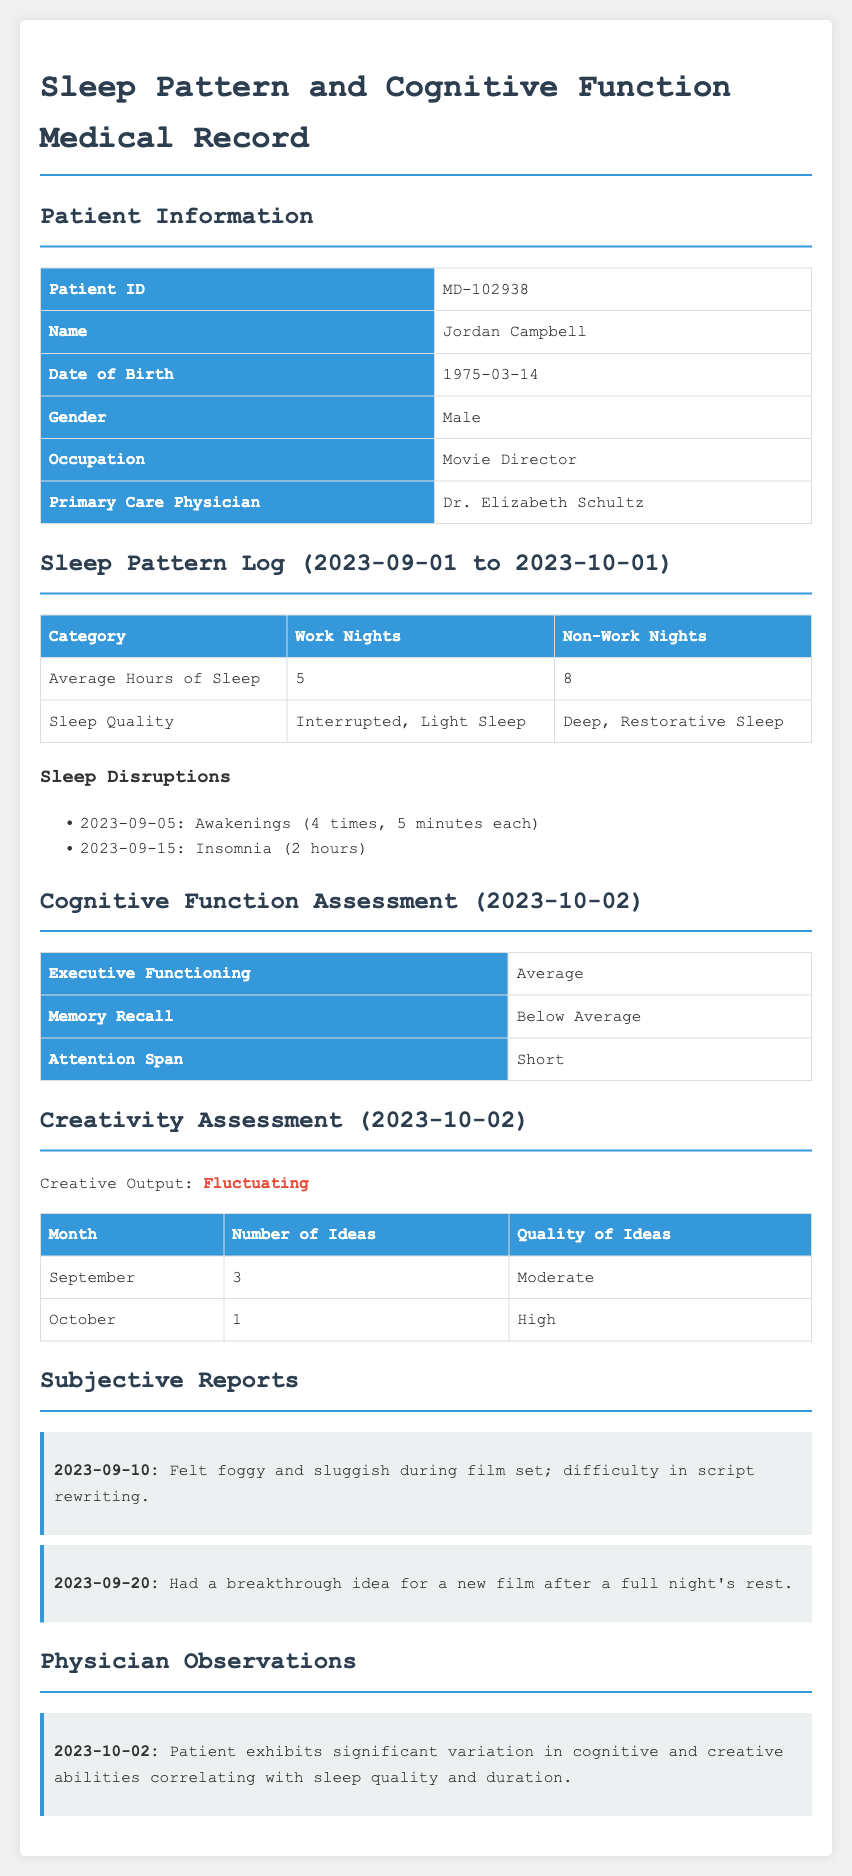What is the Patient ID? The Patient ID is a unique identifier for the patient noted in the section, which is MD-102938.
Answer: MD-102938 How many average hours of sleep did the patient get on work nights? The average hours of sleep on work nights are specified in the sleep pattern log, which is 5 hours.
Answer: 5 What was the patient's memory recall assessment result? The memory recall result can be found in the cognitive function assessment section, which is below average.
Answer: Below Average What was the quality of ideas generated in October? The quality of ideas for October is stated in the creativity assessment section, which is high.
Answer: High What did the physician observe on 2023-10-02? The physician's observation recorded the significant variations in the patient's cognitive and creative abilities, correlating with sleep quality and duration.
Answer: Significant variation What was the average sleep quality on non-work nights? The sleep quality on non-work nights is mentioned in the sleep pattern log, which is deep, restorative sleep.
Answer: Deep, Restorative Sleep How many ideas did the patient generate in September? The number of ideas generated in September is recorded in the creativity assessment section, which is 3.
Answer: 3 On what date did the patient report feeling foggy and sluggish? The specific date when the patient mentioned feeling foggy and sluggish is highlighted in the subjective reports, which is 2023-09-10.
Answer: 2023-09-10 